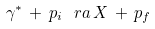Convert formula to latex. <formula><loc_0><loc_0><loc_500><loc_500>\gamma ^ { * } \, + \, p _ { i } \, \ r a \, X \, + \, p _ { f }</formula> 